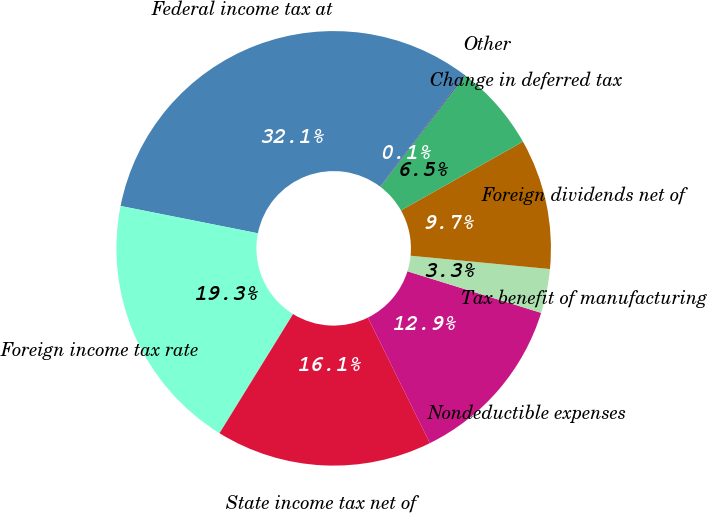Convert chart. <chart><loc_0><loc_0><loc_500><loc_500><pie_chart><fcel>Federal income tax at<fcel>Foreign income tax rate<fcel>State income tax net of<fcel>Nondeductible expenses<fcel>Tax benefit of manufacturing<fcel>Foreign dividends net of<fcel>Change in deferred tax<fcel>Other<nl><fcel>32.15%<fcel>19.32%<fcel>16.11%<fcel>12.9%<fcel>3.28%<fcel>9.69%<fcel>6.49%<fcel>0.07%<nl></chart> 